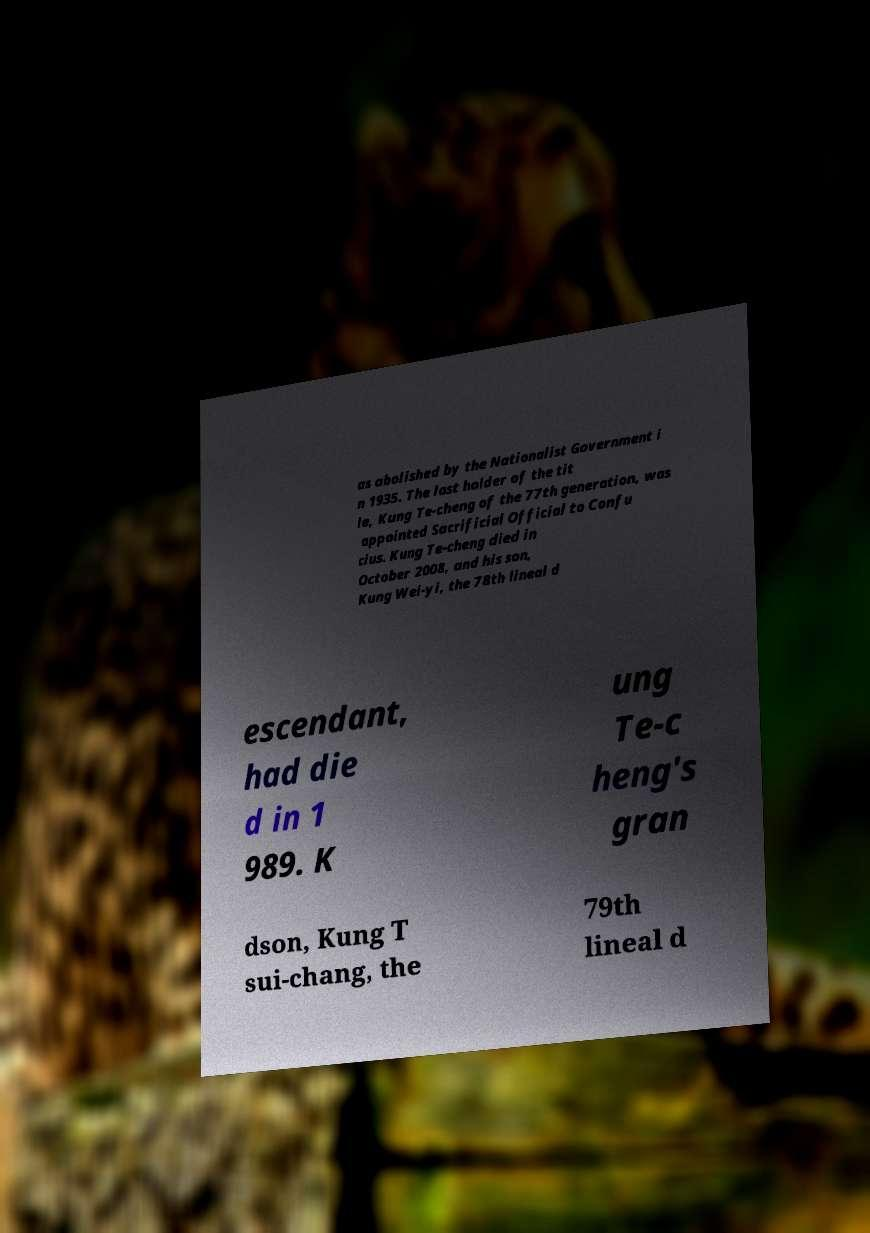Can you read and provide the text displayed in the image?This photo seems to have some interesting text. Can you extract and type it out for me? as abolished by the Nationalist Government i n 1935. The last holder of the tit le, Kung Te-cheng of the 77th generation, was appointed Sacrificial Official to Confu cius. Kung Te-cheng died in October 2008, and his son, Kung Wei-yi, the 78th lineal d escendant, had die d in 1 989. K ung Te-c heng's gran dson, Kung T sui-chang, the 79th lineal d 